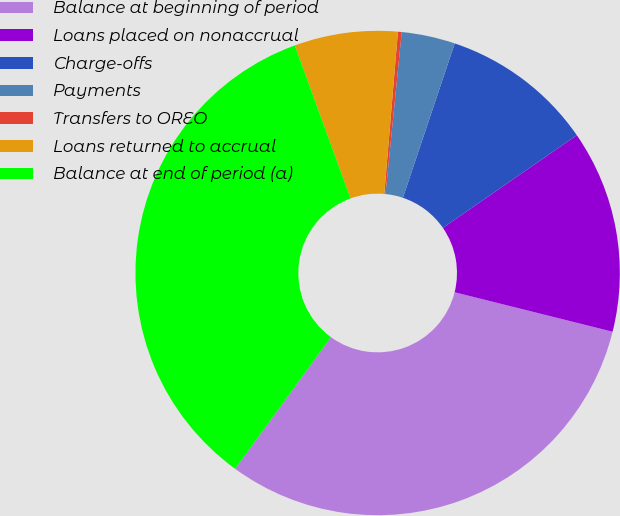Convert chart to OTSL. <chart><loc_0><loc_0><loc_500><loc_500><pie_chart><fcel>Balance at beginning of period<fcel>Loans placed on nonaccrual<fcel>Charge-offs<fcel>Payments<fcel>Transfers to OREO<fcel>Loans returned to accrual<fcel>Balance at end of period (a)<nl><fcel>31.11%<fcel>13.53%<fcel>10.21%<fcel>3.57%<fcel>0.25%<fcel>6.89%<fcel>34.43%<nl></chart> 